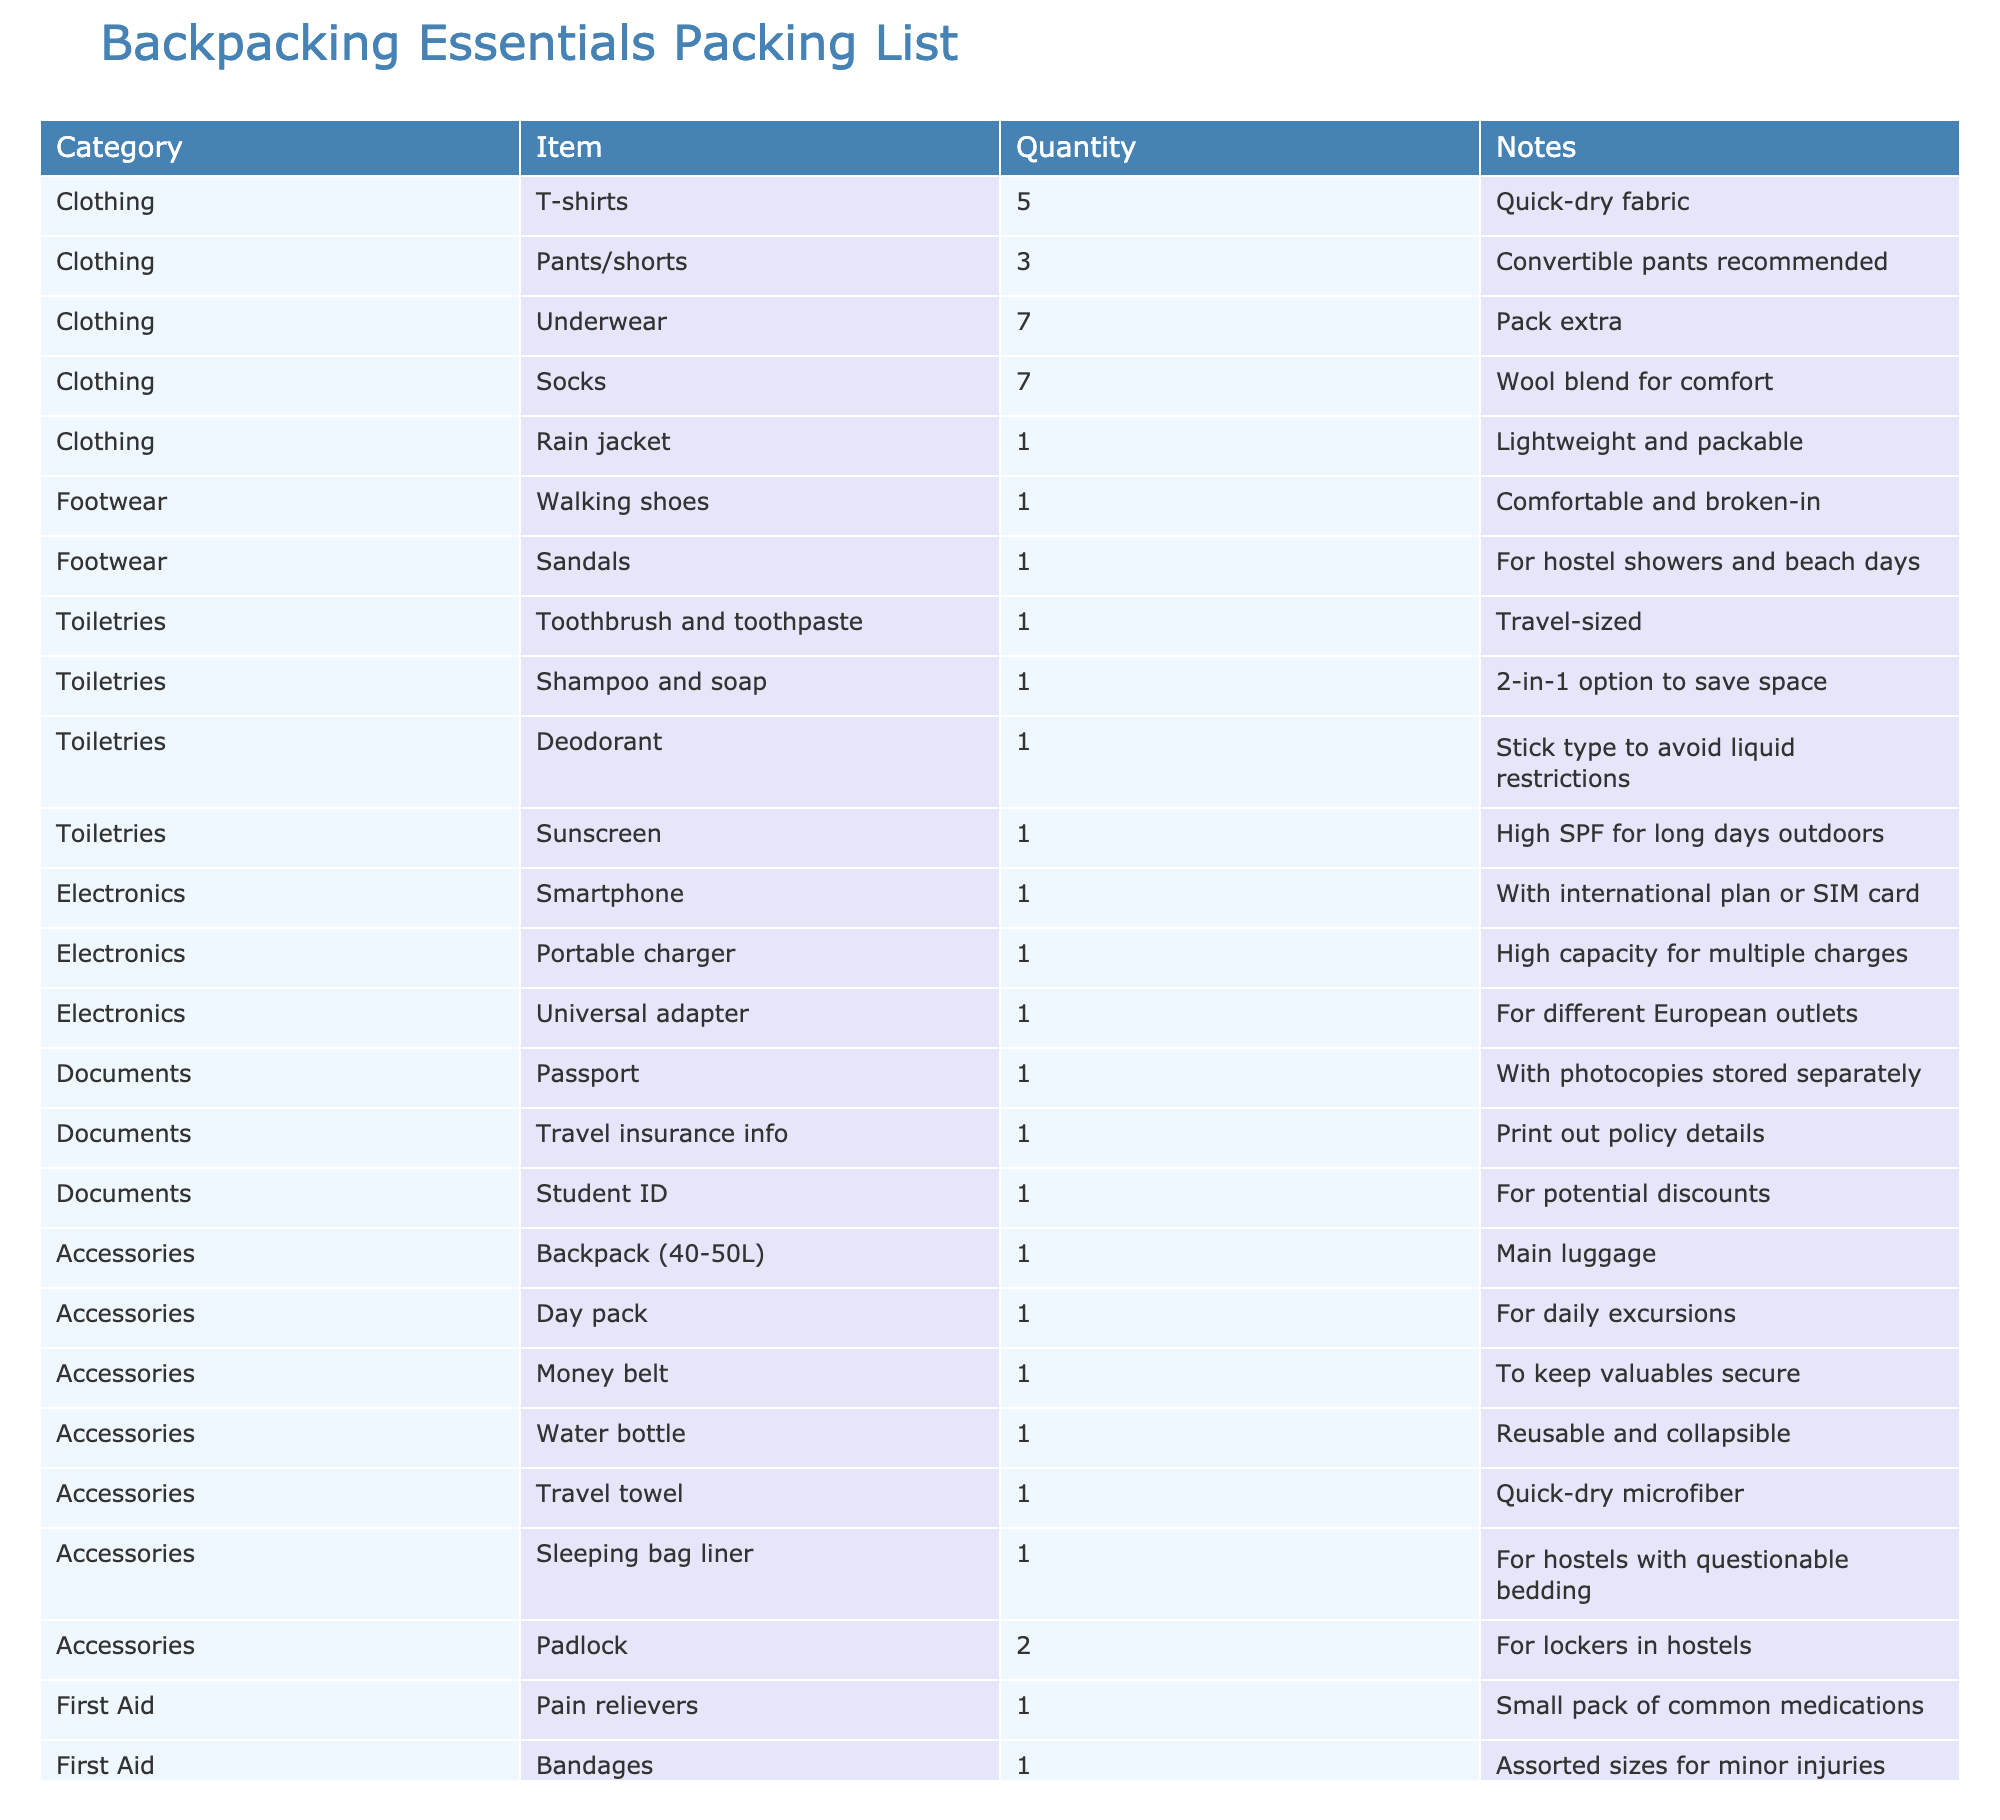What is the quantity of T-shirts listed in the packing list? The table shows a specific item under the Clothing category, which is T-shirts. The Quantity column next to it states there are 5 T-shirts listed.
Answer: 5 How many pairs of socks are included in the packing list? In the table, the Socks item under the Clothing category is listed with a quantity of 7. Thus, there are 7 pairs of socks.
Answer: 7 Is a rain jacket included among the essential items? The table features a row under the Clothing category for a rain jacket, indicating that it is included in the packing list.
Answer: Yes What is the total number of toiletry items listed? The Toiletries category has 4 items: toothbrush and toothpaste, shampoo and soap, deodorant, and sunscreen. Summing these gives a total of 4 toiletry items.
Answer: 4 Are there more clothing items than first aid items listed in the packing list? Clothing has 5 distinct items (T-shirts, pants/shorts, underwear, socks, rain jacket), while First Aid has 3 items (pain relievers, bandages, antiseptic wipes). Since 5 is greater than 3, there are more clothing items.
Answer: Yes How many total accessories are included in the packing list, and what are they? The Accessories category lists 8 items: backpack, day pack, money belt, water bottle, travel towel, sleeping bag liner, and 2 padlocks. Summing these gives a total of 8 accessories.
Answer: 8 accessories: backpack, day pack, money belt, water bottle, travel towel, sleeping bag liner, padlock (2) What is the most numerous type of clothing item in the packing list? The Clothing category shows several items. Underwear and socks are both listed with a quantity of 7 each, which is the highest among the items. Therefore, either underwear or socks can be considered the most numerous type.
Answer: Underwear and socks (7 each) How many different types of footwear are listed? The Footwear category includes 2 types of items: walking shoes and sandals. Thus, there are a total of 2 different types of footwear.
Answer: 2 types What items in the packing list are recommended for hostels? The packing list mentions the travel towel and sleeping bag liner under Accessories, and the sandals under Footwear, which are specifically noted for hostel showers. Therefore, these items are all recommended for hostel use.
Answer: Travel towel, sleeping bag liner, sandals 